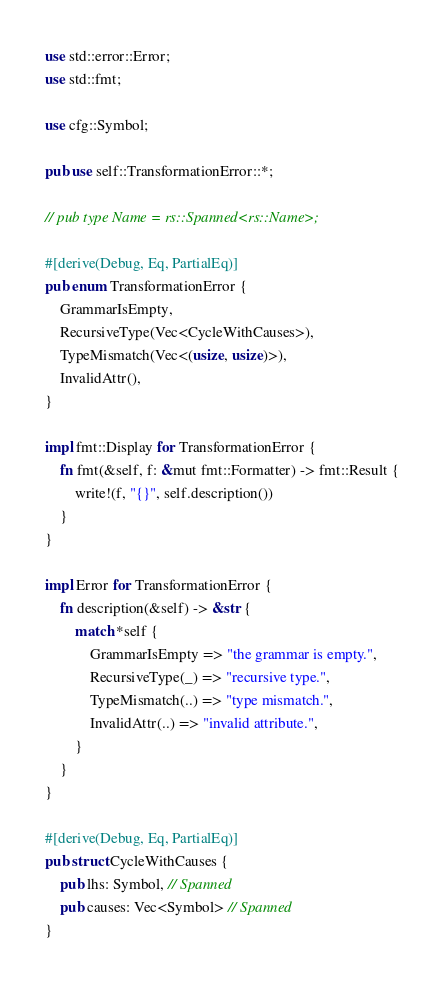Convert code to text. <code><loc_0><loc_0><loc_500><loc_500><_Rust_>use std::error::Error;
use std::fmt;

use cfg::Symbol;

pub use self::TransformationError::*;

// pub type Name = rs::Spanned<rs::Name>;

#[derive(Debug, Eq, PartialEq)]
pub enum TransformationError {
    GrammarIsEmpty,
    RecursiveType(Vec<CycleWithCauses>),
    TypeMismatch(Vec<(usize, usize)>),
    InvalidAttr(),
}

impl fmt::Display for TransformationError {
    fn fmt(&self, f: &mut fmt::Formatter) -> fmt::Result {
        write!(f, "{}", self.description())
    }
}

impl Error for TransformationError {
    fn description(&self) -> &str {
        match *self {
            GrammarIsEmpty => "the grammar is empty.",
            RecursiveType(_) => "recursive type.",
            TypeMismatch(..) => "type mismatch.",
            InvalidAttr(..) => "invalid attribute.",
        }
    }
}

#[derive(Debug, Eq, PartialEq)]
pub struct CycleWithCauses {
    pub lhs: Symbol, // Spanned
    pub causes: Vec<Symbol> // Spanned
}
</code> 